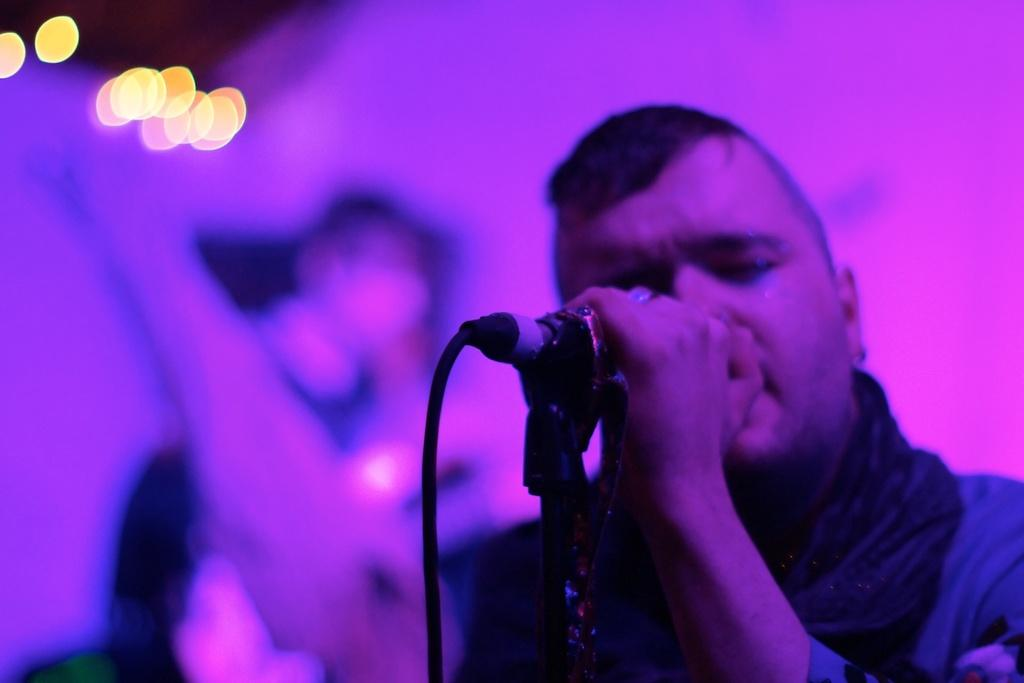Who is present in the image? There are people in the image. What is the man holding in the image? The man is holding a microphone. What can be seen in the background of the image? There are lights visible in the background of the image. How many rabbits can be seen in the image? There are no rabbits present in the image. What unit of measurement is the man using to hold the microphone? The man is not using any unit of measurement to hold the microphone; he is simply holding it. 